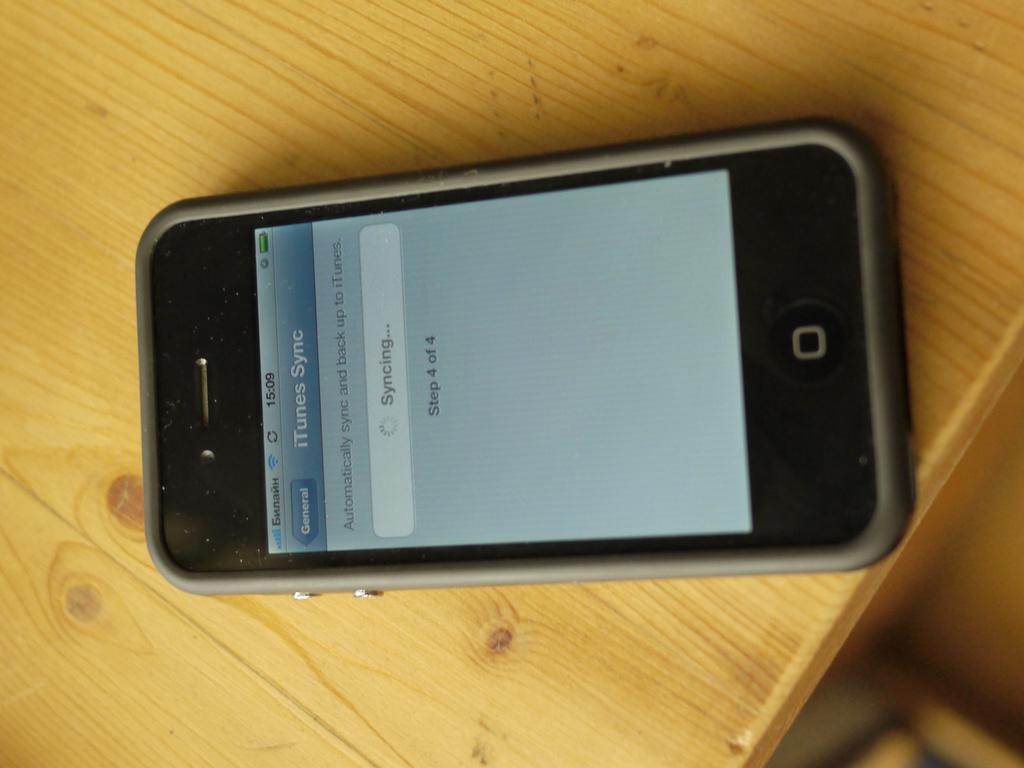What is being sync?
Offer a terse response. Itunes. What is the time displayed?
Make the answer very short. 15:09. 